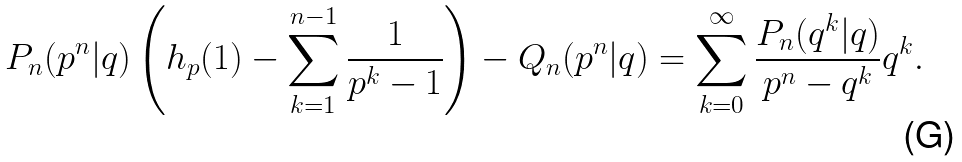<formula> <loc_0><loc_0><loc_500><loc_500>P _ { n } ( p ^ { n } | q ) \left ( h _ { p } ( 1 ) - \sum _ { k = 1 } ^ { n - 1 } \frac { 1 } { p ^ { k } - 1 } \right ) - Q _ { n } ( p ^ { n } | q ) = \sum _ { k = 0 } ^ { \infty } \frac { P _ { n } ( q ^ { k } | q ) } { p ^ { n } - q ^ { k } } q ^ { k } .</formula> 